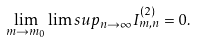<formula> <loc_0><loc_0><loc_500><loc_500>\lim _ { m \to m _ { 0 } } \lim s u p _ { n \to \infty } I _ { m , n } ^ { ( 2 ) } = 0 .</formula> 